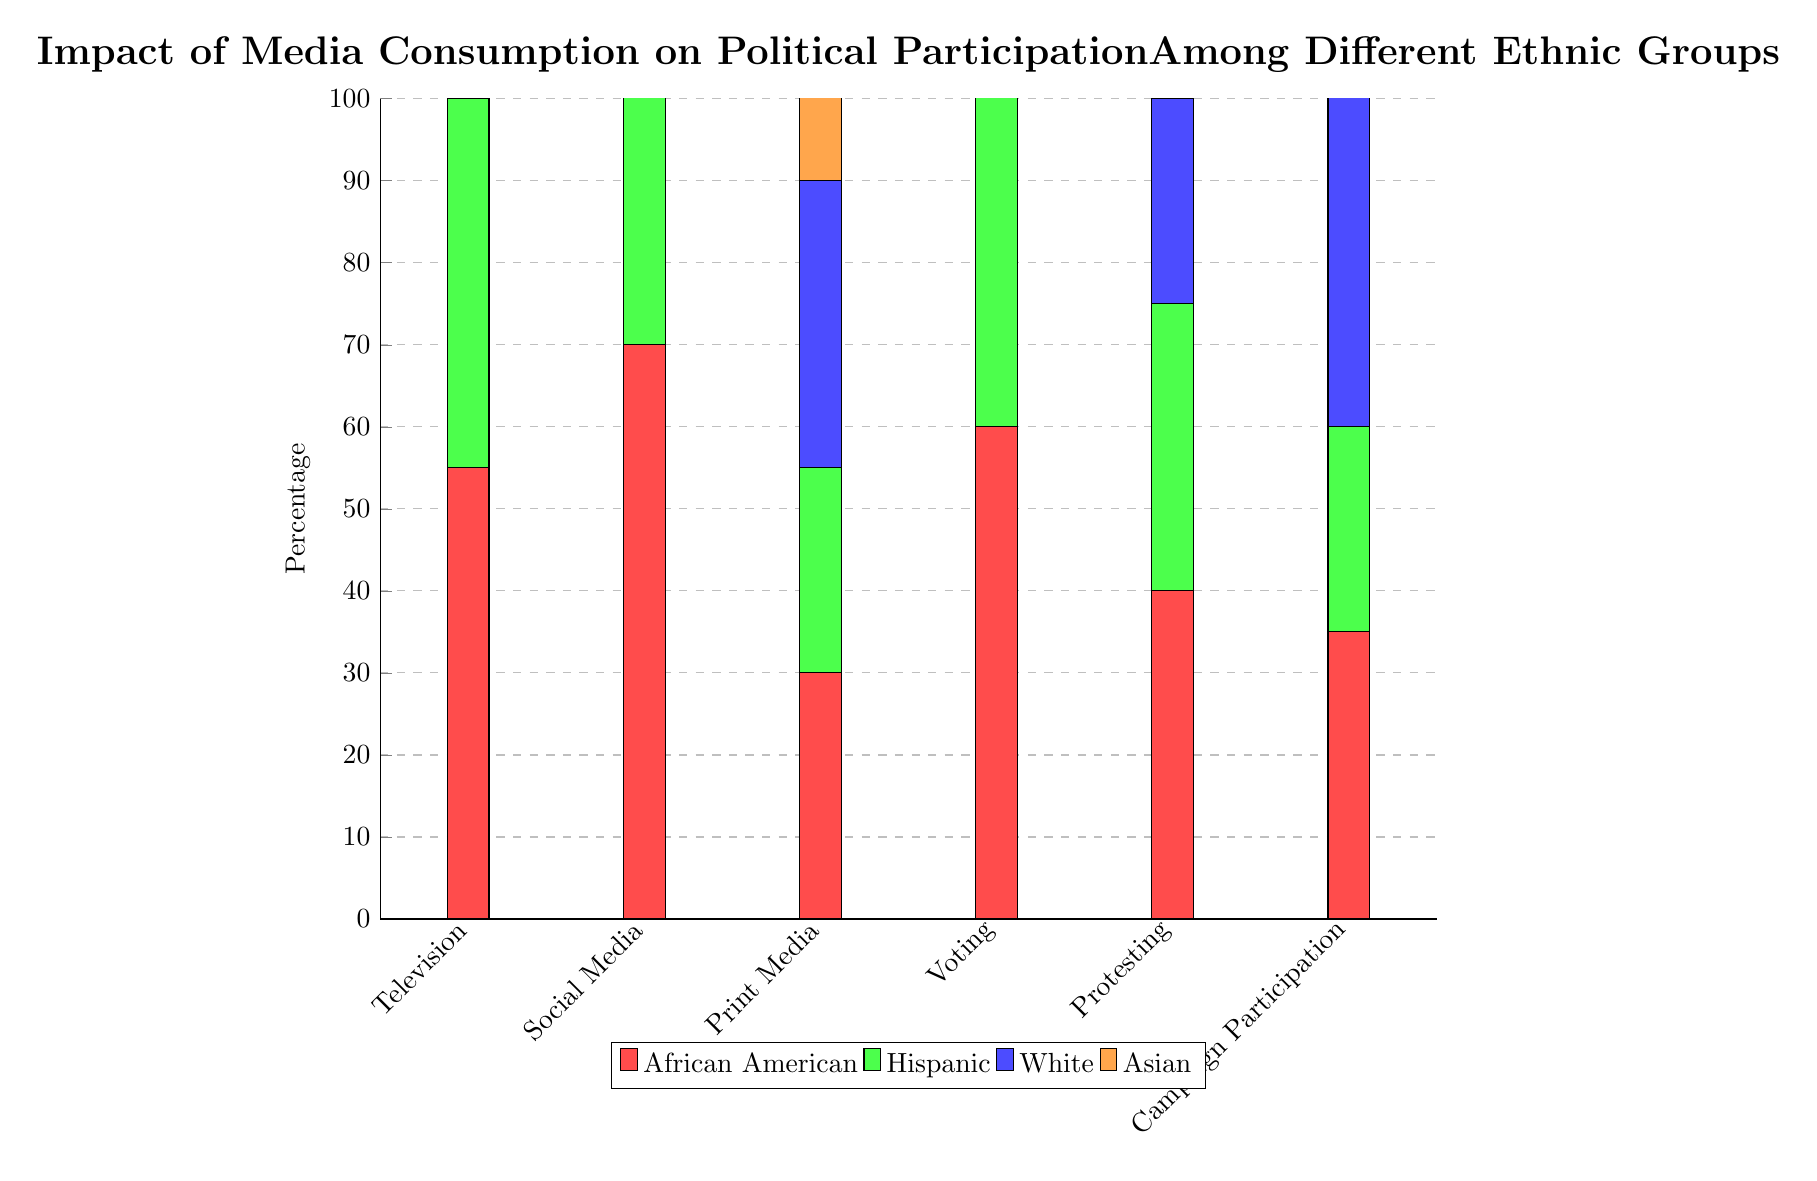What percentage of Asian individuals consume television media? From the diagram, the segment that corresponds to Asian individuals under the Television category shows a value of 40.
Answer: 40 What is the highest percentage of political participation in voting across ethnic groups? In the Voting category, the highest value is marked by the White group at 80, indicating its peak level of participation among all groups.
Answer: 80 Which ethnic group has the lowest percentage of print media consumption? The Print Media section reveals that the Hispanic group has the lowest percentage at 25, compared to the other ethnic groups.
Answer: 25 Is there any ethnic group that participates more in campaigning than in protesting? By examining the Campaign Participation and Protesting values, the Asian group shows 45 in campaigning and only 25 in protesting, confirming that they participate more in campaigning.
Answer: Yes What is the total percentage of the African American group's political participation activities when considering voting, protesting, and campaign participation? Adding the percentages of Voting (60), Protesting (40), and Campaign Participation (35) gives a total of 135 for African American political participation activities.
Answer: 135 Which ethnic group shows the highest consumption of social media? The Social Media category reveals Asians have the highest percentage of media consumption at 75, marking them as the leading ethnic group in this aspect.
Answer: 75 What trend can be observed between media consumption and campaigning for the African American group? Analyzing the data, the African American group has declining participation in campaigning (35) despite higher consumption in both Television (55) and Social Media (70), indicating an inverse relationship.
Answer: Inverse relationship Which media type has the highest consumption percentage among Hispanics? Reviewing the categories for Hispanics, Social Media shows the highest consumption percentage at 65, making it the top media type for this group.
Answer: 65 